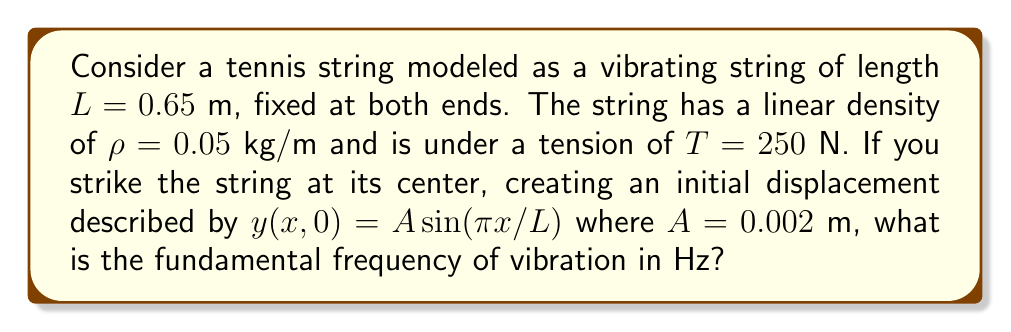Solve this math problem. To solve this problem, we'll follow these steps:

1) The wave equation for a vibrating string is:

   $$\frac{\partial^2 y}{\partial t^2} = v^2 \frac{\partial^2 y}{\partial x^2}$$

   where $v$ is the wave speed.

2) The wave speed $v$ is given by:

   $$v = \sqrt{\frac{T}{\rho}}$$

3) Substituting the given values:

   $$v = \sqrt{\frac{250 \text{ N}}{0.05 \text{ kg/m}}} = \sqrt{5000} \approx 70.71 \text{ m/s}$$

4) For a string fixed at both ends, the fundamental frequency $f_1$ is given by:

   $$f_1 = \frac{v}{2L}$$

5) Substituting the values:

   $$f_1 = \frac{70.71 \text{ m/s}}{2(0.65 \text{ m})} \approx 54.39 \text{ Hz}$$

6) Rounding to two decimal places:

   $$f_1 \approx 54.39 \text{ Hz}$$

Note: The initial displacement $y(x,0) = A\sin(\pi x/L)$ confirms that we're dealing with the fundamental mode of vibration, but it doesn't affect the calculation of the fundamental frequency.
Answer: 54.39 Hz 